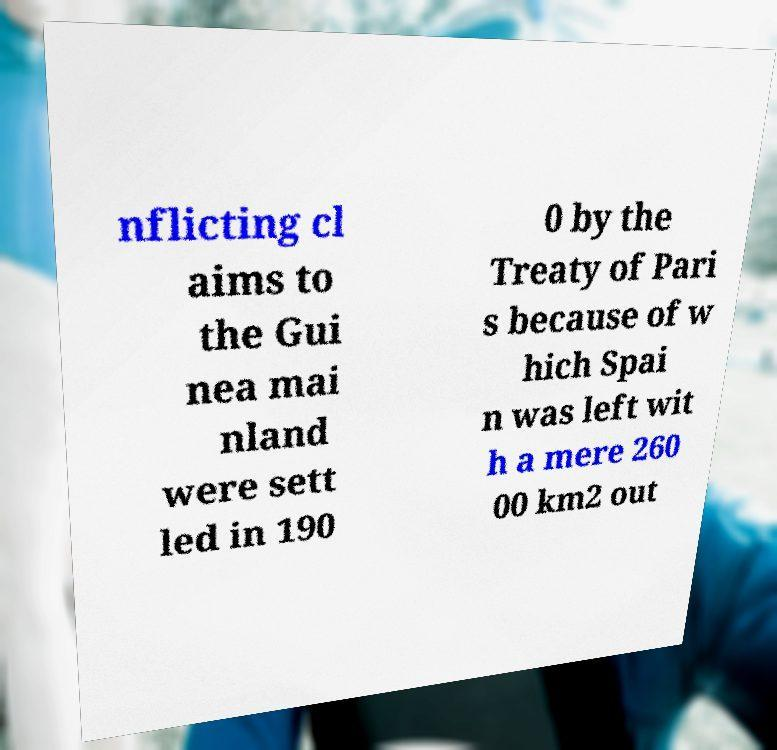What messages or text are displayed in this image? I need them in a readable, typed format. nflicting cl aims to the Gui nea mai nland were sett led in 190 0 by the Treaty of Pari s because of w hich Spai n was left wit h a mere 260 00 km2 out 